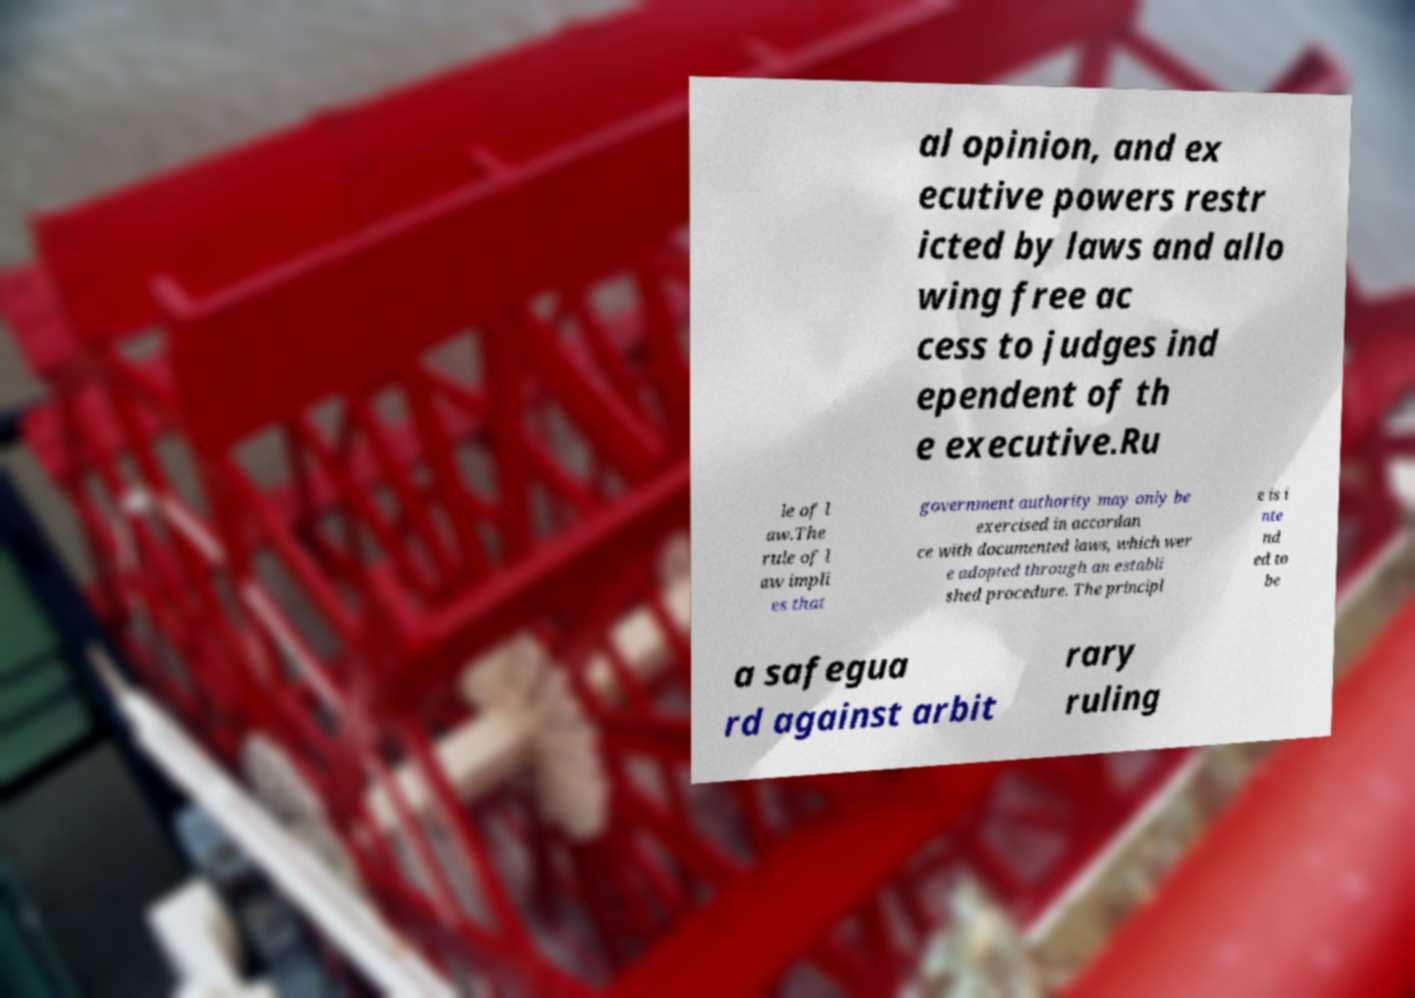For documentation purposes, I need the text within this image transcribed. Could you provide that? al opinion, and ex ecutive powers restr icted by laws and allo wing free ac cess to judges ind ependent of th e executive.Ru le of l aw.The rule of l aw impli es that government authority may only be exercised in accordan ce with documented laws, which wer e adopted through an establi shed procedure. The principl e is i nte nd ed to be a safegua rd against arbit rary ruling 